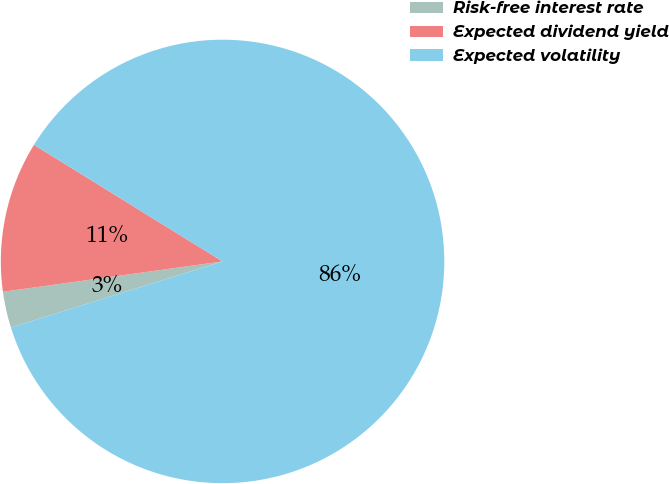<chart> <loc_0><loc_0><loc_500><loc_500><pie_chart><fcel>Risk-free interest rate<fcel>Expected dividend yield<fcel>Expected volatility<nl><fcel>2.63%<fcel>11.0%<fcel>86.37%<nl></chart> 